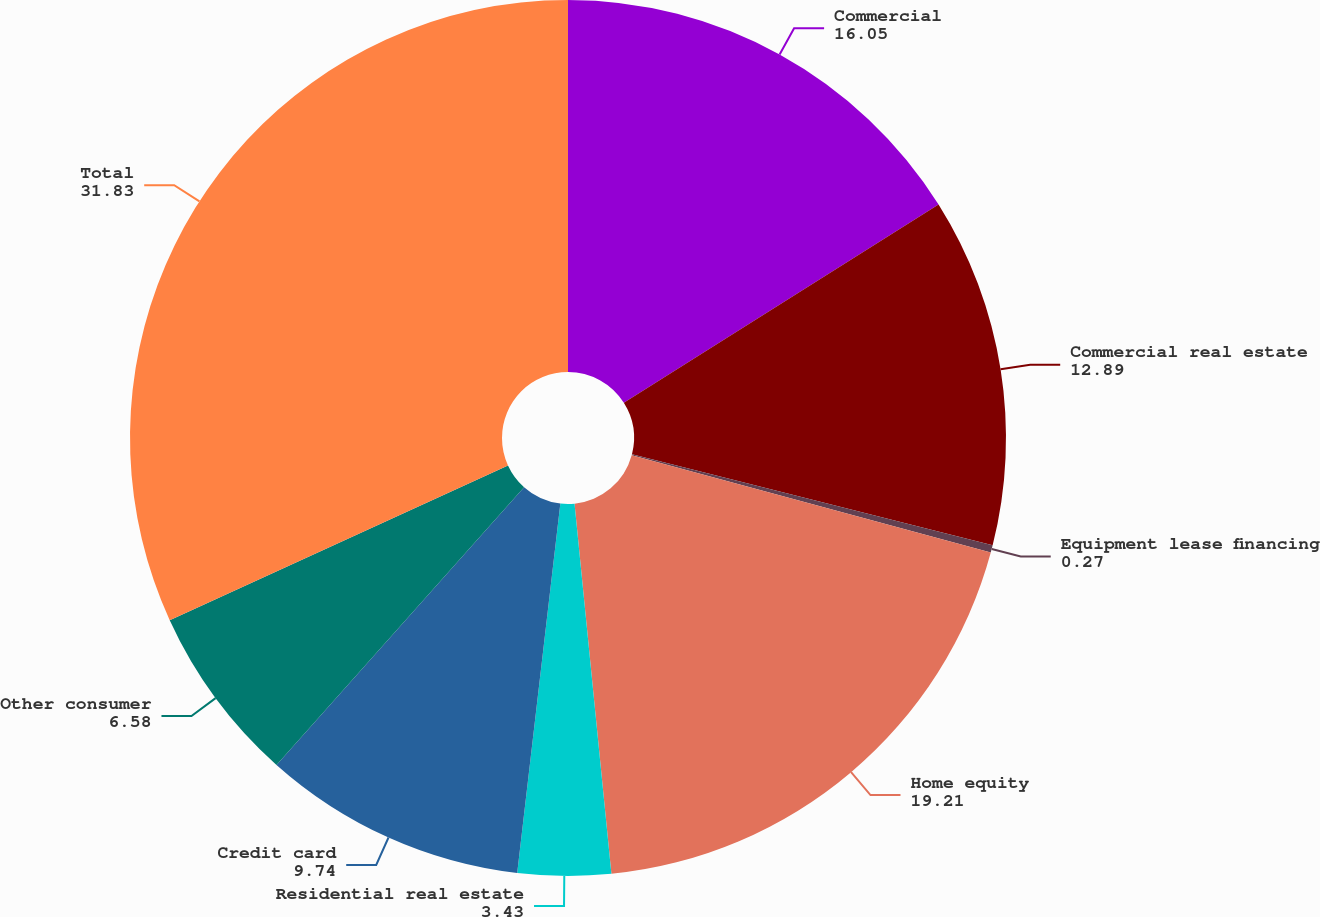<chart> <loc_0><loc_0><loc_500><loc_500><pie_chart><fcel>Commercial<fcel>Commercial real estate<fcel>Equipment lease financing<fcel>Home equity<fcel>Residential real estate<fcel>Credit card<fcel>Other consumer<fcel>Total<nl><fcel>16.05%<fcel>12.89%<fcel>0.27%<fcel>19.21%<fcel>3.43%<fcel>9.74%<fcel>6.58%<fcel>31.83%<nl></chart> 